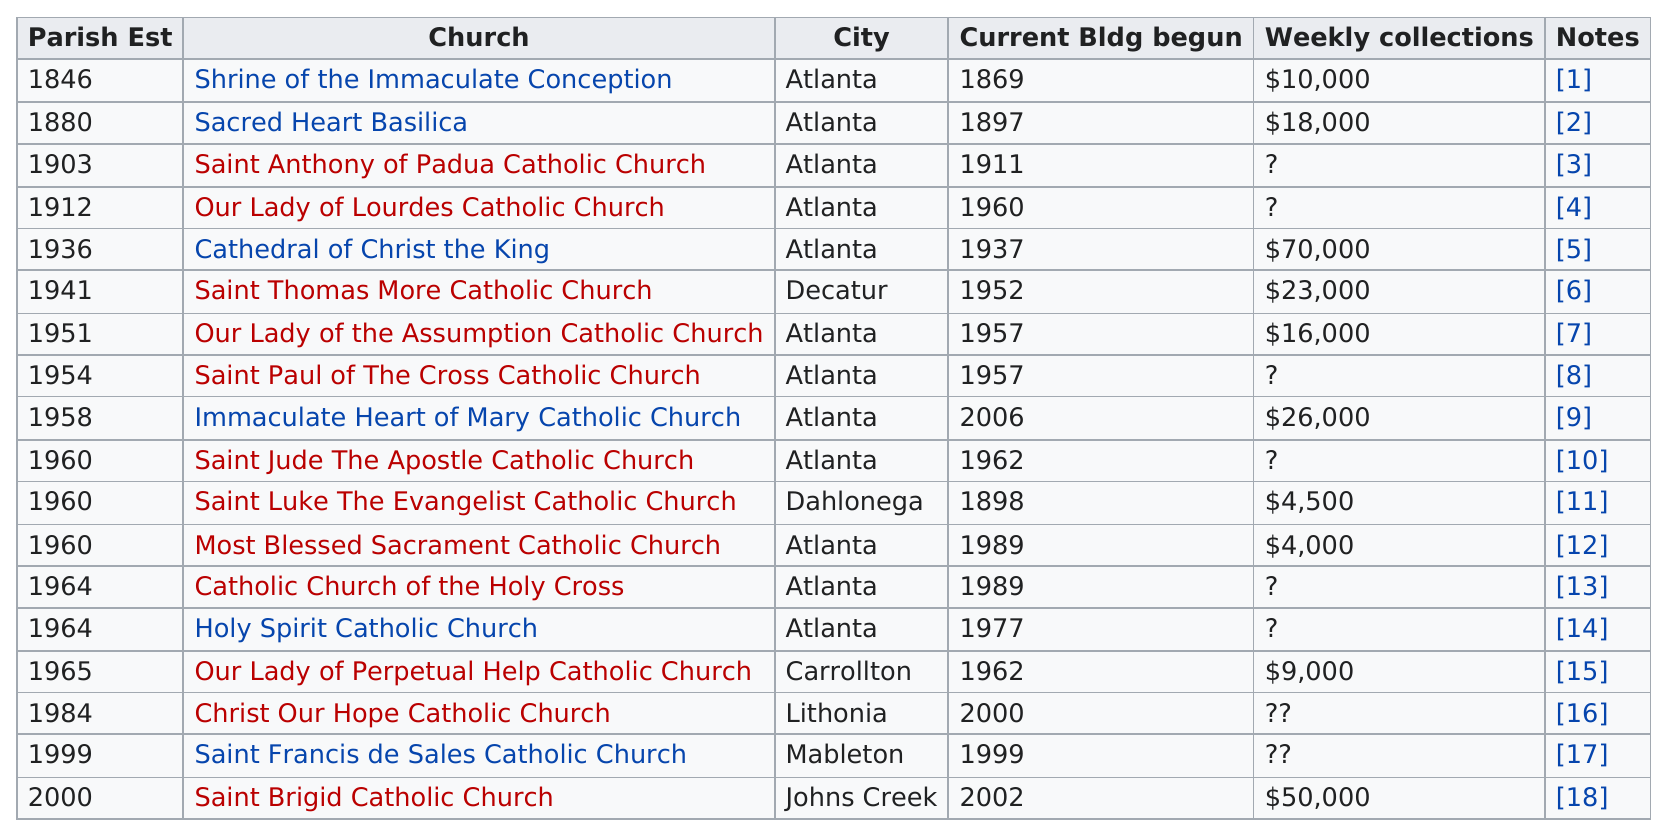Mention a couple of crucial points in this snapshot. In 1964, each of the parishes was established in the city where it was located. For example, the Atlanta parish was established in Atlanta. Sacred Heart Basilica has been established for 134 years. The weekly collections at Cathedral of Christ the King are $66,000 more than the collections at Most Blessed Sacrament Catholic Church. The Cathedral of Christ the King is a church that has the highest weekly collections. Saint Brigid Catholic Church in Atlanta has weekly collections in excess of $25,000. 